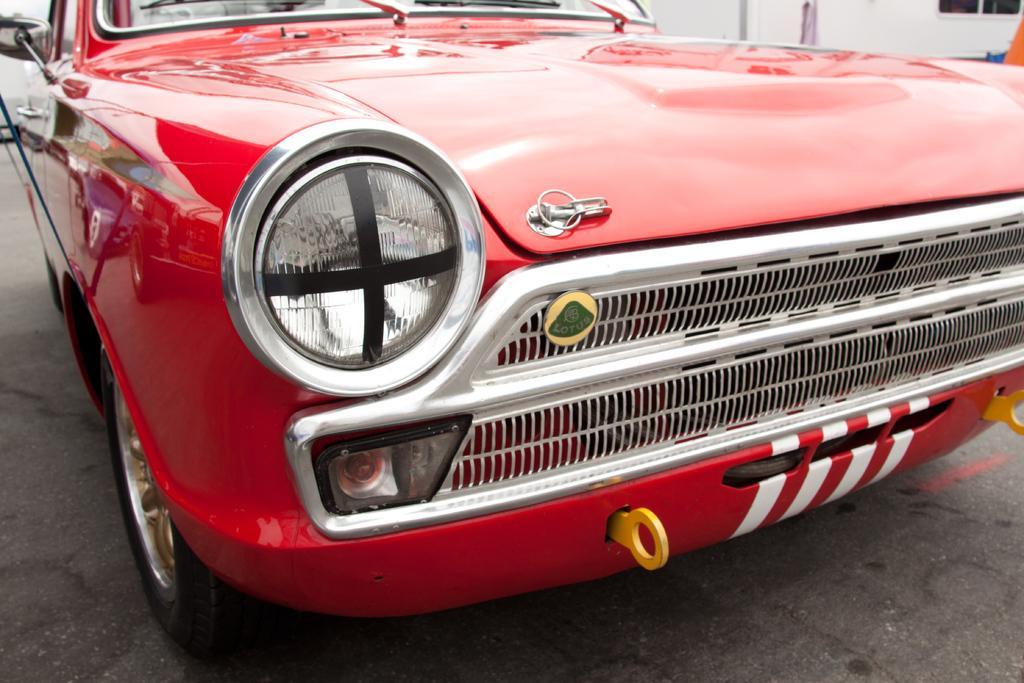Can you describe this image briefly? In this image, we can see a car which is colored red. 